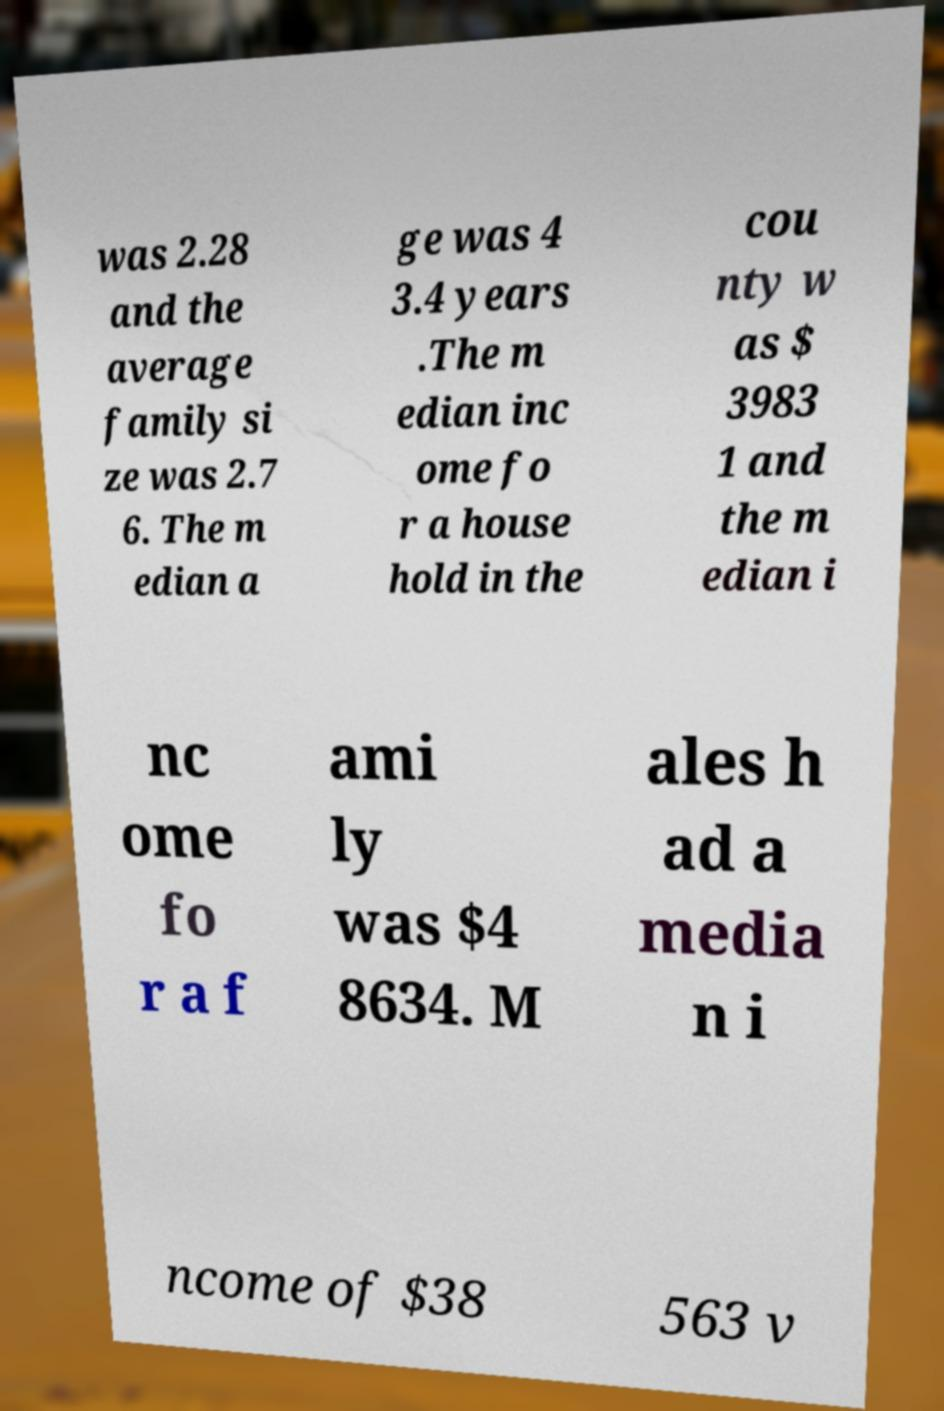What messages or text are displayed in this image? I need them in a readable, typed format. was 2.28 and the average family si ze was 2.7 6. The m edian a ge was 4 3.4 years .The m edian inc ome fo r a house hold in the cou nty w as $ 3983 1 and the m edian i nc ome fo r a f ami ly was $4 8634. M ales h ad a media n i ncome of $38 563 v 